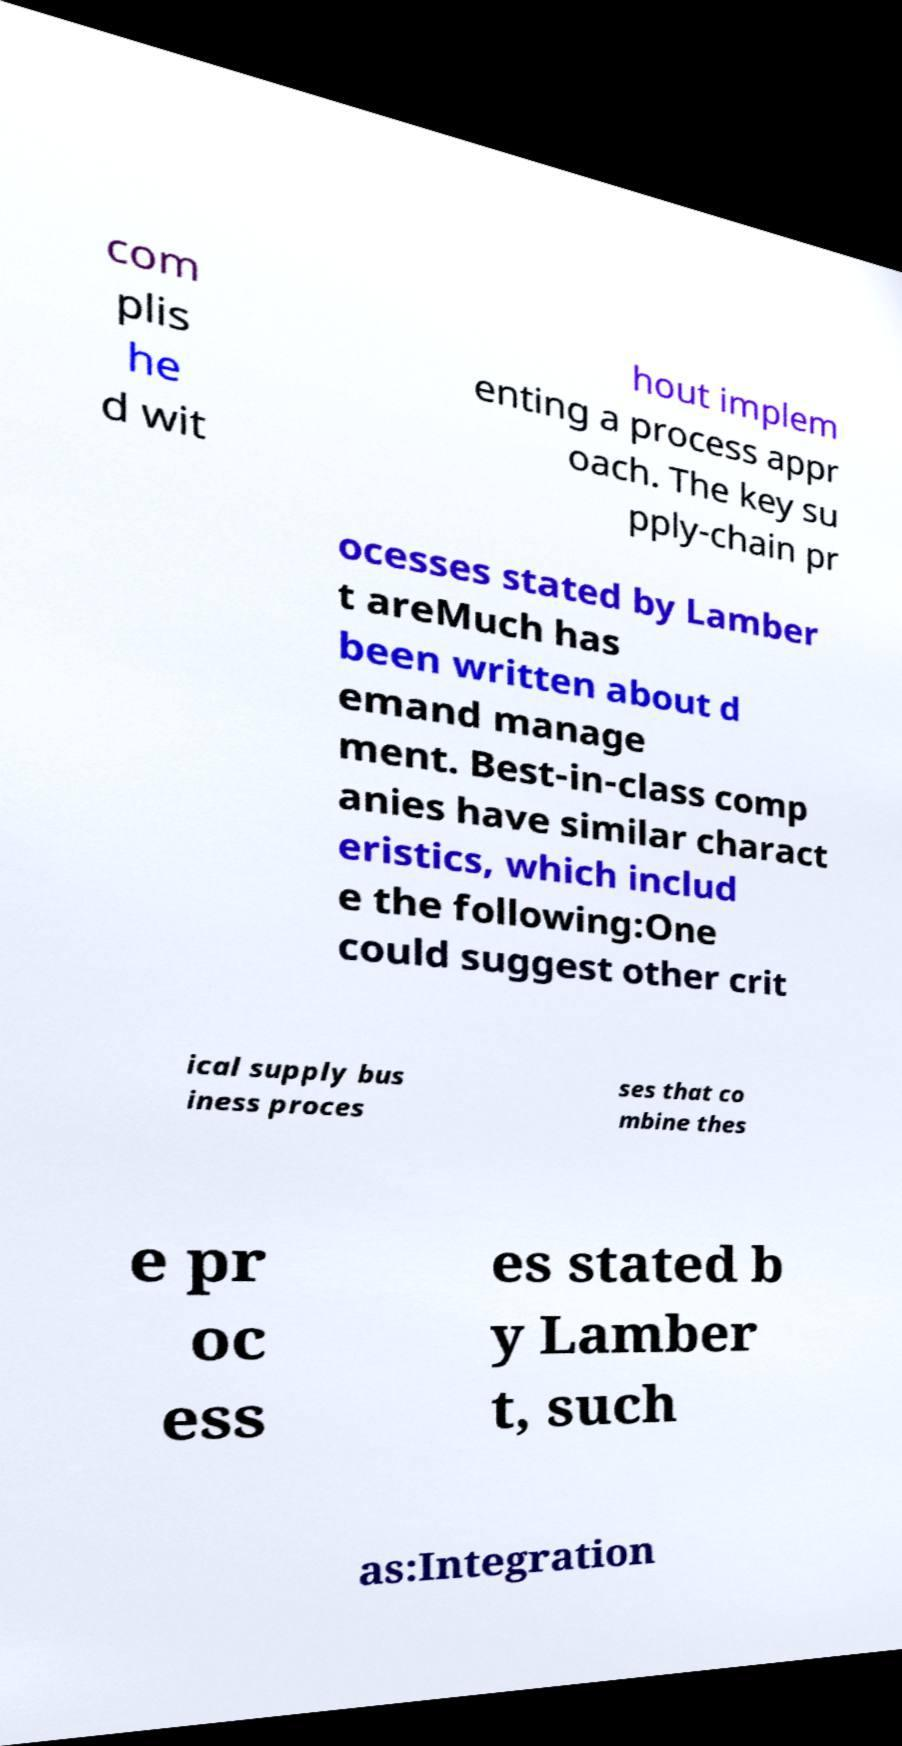Could you assist in decoding the text presented in this image and type it out clearly? com plis he d wit hout implem enting a process appr oach. The key su pply-chain pr ocesses stated by Lamber t areMuch has been written about d emand manage ment. Best-in-class comp anies have similar charact eristics, which includ e the following:One could suggest other crit ical supply bus iness proces ses that co mbine thes e pr oc ess es stated b y Lamber t, such as:Integration 